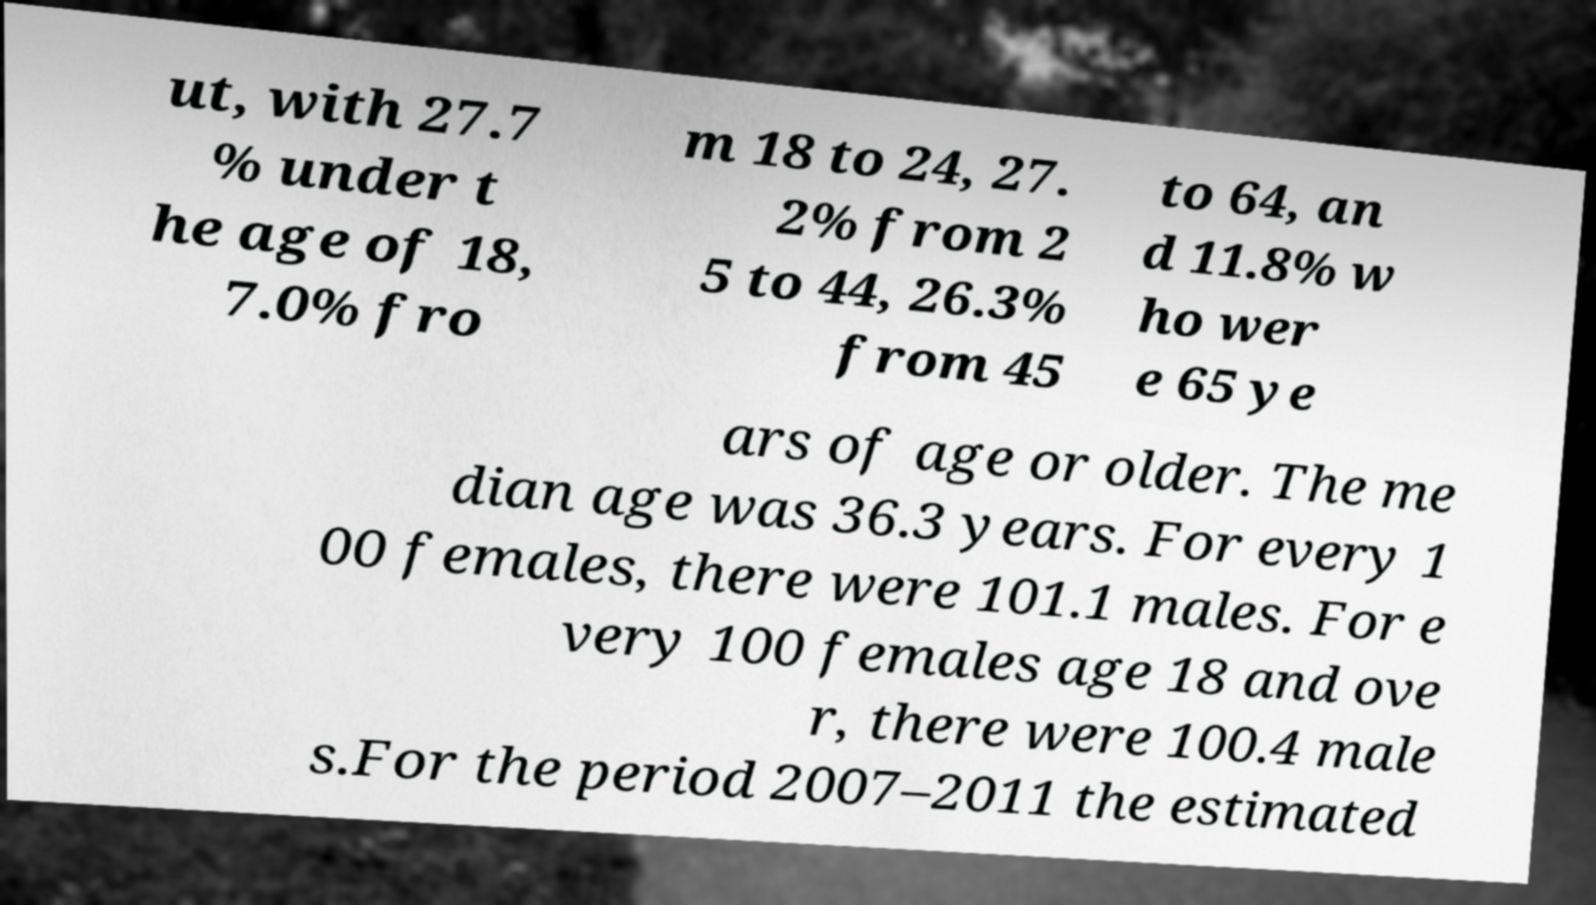For documentation purposes, I need the text within this image transcribed. Could you provide that? ut, with 27.7 % under t he age of 18, 7.0% fro m 18 to 24, 27. 2% from 2 5 to 44, 26.3% from 45 to 64, an d 11.8% w ho wer e 65 ye ars of age or older. The me dian age was 36.3 years. For every 1 00 females, there were 101.1 males. For e very 100 females age 18 and ove r, there were 100.4 male s.For the period 2007–2011 the estimated 